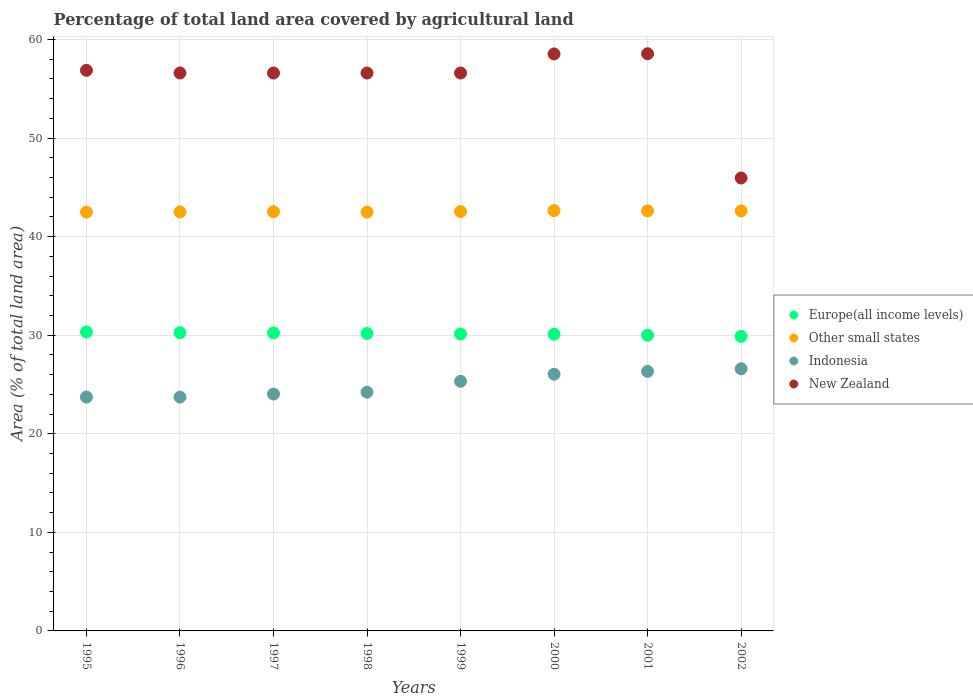What is the percentage of agricultural land in New Zealand in 1996?
Ensure brevity in your answer.  56.6. Across all years, what is the maximum percentage of agricultural land in Indonesia?
Give a very brief answer. 26.6. Across all years, what is the minimum percentage of agricultural land in New Zealand?
Your answer should be very brief. 45.95. In which year was the percentage of agricultural land in Other small states maximum?
Ensure brevity in your answer.  2000. What is the total percentage of agricultural land in Other small states in the graph?
Your answer should be compact. 340.41. What is the difference between the percentage of agricultural land in New Zealand in 1995 and that in 2000?
Offer a very short reply. -1.66. What is the difference between the percentage of agricultural land in New Zealand in 1998 and the percentage of agricultural land in Indonesia in 1997?
Your response must be concise. 32.57. What is the average percentage of agricultural land in Other small states per year?
Offer a terse response. 42.55. In the year 1999, what is the difference between the percentage of agricultural land in New Zealand and percentage of agricultural land in Europe(all income levels)?
Give a very brief answer. 26.47. What is the ratio of the percentage of agricultural land in Europe(all income levels) in 1997 to that in 2000?
Give a very brief answer. 1. Is the percentage of agricultural land in Indonesia in 1998 less than that in 2000?
Keep it short and to the point. Yes. Is the difference between the percentage of agricultural land in New Zealand in 1995 and 1999 greater than the difference between the percentage of agricultural land in Europe(all income levels) in 1995 and 1999?
Ensure brevity in your answer.  Yes. What is the difference between the highest and the second highest percentage of agricultural land in Indonesia?
Offer a very short reply. 0.27. What is the difference between the highest and the lowest percentage of agricultural land in Europe(all income levels)?
Provide a succinct answer. 0.45. Is the sum of the percentage of agricultural land in Europe(all income levels) in 2000 and 2001 greater than the maximum percentage of agricultural land in Indonesia across all years?
Keep it short and to the point. Yes. Is it the case that in every year, the sum of the percentage of agricultural land in Indonesia and percentage of agricultural land in New Zealand  is greater than the percentage of agricultural land in Other small states?
Offer a very short reply. Yes. Is the percentage of agricultural land in Other small states strictly greater than the percentage of agricultural land in Indonesia over the years?
Your answer should be very brief. Yes. Is the percentage of agricultural land in Europe(all income levels) strictly less than the percentage of agricultural land in Other small states over the years?
Provide a succinct answer. Yes. How many dotlines are there?
Your answer should be compact. 4. How many years are there in the graph?
Give a very brief answer. 8. What is the difference between two consecutive major ticks on the Y-axis?
Ensure brevity in your answer.  10. Does the graph contain any zero values?
Ensure brevity in your answer.  No. Where does the legend appear in the graph?
Your answer should be compact. Center right. What is the title of the graph?
Your answer should be very brief. Percentage of total land area covered by agricultural land. What is the label or title of the X-axis?
Provide a short and direct response. Years. What is the label or title of the Y-axis?
Give a very brief answer. Area (% of total land area). What is the Area (% of total land area) of Europe(all income levels) in 1995?
Ensure brevity in your answer.  30.33. What is the Area (% of total land area) of Other small states in 1995?
Offer a terse response. 42.49. What is the Area (% of total land area) in Indonesia in 1995?
Your response must be concise. 23.72. What is the Area (% of total land area) of New Zealand in 1995?
Ensure brevity in your answer.  56.87. What is the Area (% of total land area) of Europe(all income levels) in 1996?
Ensure brevity in your answer.  30.25. What is the Area (% of total land area) of Other small states in 1996?
Ensure brevity in your answer.  42.51. What is the Area (% of total land area) in Indonesia in 1996?
Your answer should be very brief. 23.72. What is the Area (% of total land area) of New Zealand in 1996?
Ensure brevity in your answer.  56.6. What is the Area (% of total land area) in Europe(all income levels) in 1997?
Your answer should be compact. 30.23. What is the Area (% of total land area) of Other small states in 1997?
Provide a short and direct response. 42.53. What is the Area (% of total land area) in Indonesia in 1997?
Your answer should be compact. 24.03. What is the Area (% of total land area) of New Zealand in 1997?
Keep it short and to the point. 56.6. What is the Area (% of total land area) of Europe(all income levels) in 1998?
Provide a succinct answer. 30.18. What is the Area (% of total land area) of Other small states in 1998?
Keep it short and to the point. 42.49. What is the Area (% of total land area) of Indonesia in 1998?
Offer a very short reply. 24.22. What is the Area (% of total land area) in New Zealand in 1998?
Provide a short and direct response. 56.6. What is the Area (% of total land area) in Europe(all income levels) in 1999?
Provide a short and direct response. 30.12. What is the Area (% of total land area) in Other small states in 1999?
Your answer should be very brief. 42.55. What is the Area (% of total land area) of Indonesia in 1999?
Make the answer very short. 25.32. What is the Area (% of total land area) in New Zealand in 1999?
Your response must be concise. 56.6. What is the Area (% of total land area) in Europe(all income levels) in 2000?
Your answer should be very brief. 30.1. What is the Area (% of total land area) in Other small states in 2000?
Give a very brief answer. 42.64. What is the Area (% of total land area) in Indonesia in 2000?
Make the answer very short. 26.04. What is the Area (% of total land area) in New Zealand in 2000?
Offer a very short reply. 58.54. What is the Area (% of total land area) in Europe(all income levels) in 2001?
Give a very brief answer. 30. What is the Area (% of total land area) of Other small states in 2001?
Provide a succinct answer. 42.61. What is the Area (% of total land area) in Indonesia in 2001?
Make the answer very short. 26.33. What is the Area (% of total land area) of New Zealand in 2001?
Ensure brevity in your answer.  58.55. What is the Area (% of total land area) in Europe(all income levels) in 2002?
Make the answer very short. 29.88. What is the Area (% of total land area) in Other small states in 2002?
Give a very brief answer. 42.61. What is the Area (% of total land area) of Indonesia in 2002?
Your answer should be very brief. 26.6. What is the Area (% of total land area) of New Zealand in 2002?
Keep it short and to the point. 45.95. Across all years, what is the maximum Area (% of total land area) of Europe(all income levels)?
Your answer should be compact. 30.33. Across all years, what is the maximum Area (% of total land area) of Other small states?
Your answer should be very brief. 42.64. Across all years, what is the maximum Area (% of total land area) of Indonesia?
Give a very brief answer. 26.6. Across all years, what is the maximum Area (% of total land area) in New Zealand?
Your answer should be compact. 58.55. Across all years, what is the minimum Area (% of total land area) in Europe(all income levels)?
Offer a very short reply. 29.88. Across all years, what is the minimum Area (% of total land area) of Other small states?
Provide a succinct answer. 42.49. Across all years, what is the minimum Area (% of total land area) in Indonesia?
Make the answer very short. 23.72. Across all years, what is the minimum Area (% of total land area) in New Zealand?
Make the answer very short. 45.95. What is the total Area (% of total land area) of Europe(all income levels) in the graph?
Give a very brief answer. 241.1. What is the total Area (% of total land area) of Other small states in the graph?
Your answer should be compact. 340.41. What is the total Area (% of total land area) of Indonesia in the graph?
Offer a very short reply. 199.98. What is the total Area (% of total land area) in New Zealand in the graph?
Your answer should be very brief. 446.31. What is the difference between the Area (% of total land area) in Europe(all income levels) in 1995 and that in 1996?
Offer a very short reply. 0.08. What is the difference between the Area (% of total land area) of Other small states in 1995 and that in 1996?
Make the answer very short. -0.02. What is the difference between the Area (% of total land area) of Indonesia in 1995 and that in 1996?
Provide a short and direct response. 0.01. What is the difference between the Area (% of total land area) of New Zealand in 1995 and that in 1996?
Offer a terse response. 0.27. What is the difference between the Area (% of total land area) in Europe(all income levels) in 1995 and that in 1997?
Your answer should be very brief. 0.1. What is the difference between the Area (% of total land area) of Other small states in 1995 and that in 1997?
Your response must be concise. -0.04. What is the difference between the Area (% of total land area) of Indonesia in 1995 and that in 1997?
Give a very brief answer. -0.3. What is the difference between the Area (% of total land area) of New Zealand in 1995 and that in 1997?
Offer a very short reply. 0.27. What is the difference between the Area (% of total land area) of Europe(all income levels) in 1995 and that in 1998?
Provide a succinct answer. 0.16. What is the difference between the Area (% of total land area) in Other small states in 1995 and that in 1998?
Offer a terse response. -0. What is the difference between the Area (% of total land area) in Indonesia in 1995 and that in 1998?
Offer a terse response. -0.5. What is the difference between the Area (% of total land area) in New Zealand in 1995 and that in 1998?
Your response must be concise. 0.27. What is the difference between the Area (% of total land area) in Europe(all income levels) in 1995 and that in 1999?
Offer a very short reply. 0.21. What is the difference between the Area (% of total land area) of Other small states in 1995 and that in 1999?
Ensure brevity in your answer.  -0.06. What is the difference between the Area (% of total land area) in Indonesia in 1995 and that in 1999?
Make the answer very short. -1.6. What is the difference between the Area (% of total land area) of New Zealand in 1995 and that in 1999?
Offer a terse response. 0.27. What is the difference between the Area (% of total land area) in Europe(all income levels) in 1995 and that in 2000?
Provide a short and direct response. 0.23. What is the difference between the Area (% of total land area) in Other small states in 1995 and that in 2000?
Provide a succinct answer. -0.15. What is the difference between the Area (% of total land area) in Indonesia in 1995 and that in 2000?
Give a very brief answer. -2.32. What is the difference between the Area (% of total land area) of New Zealand in 1995 and that in 2000?
Your answer should be compact. -1.66. What is the difference between the Area (% of total land area) of Europe(all income levels) in 1995 and that in 2001?
Offer a terse response. 0.34. What is the difference between the Area (% of total land area) of Other small states in 1995 and that in 2001?
Your answer should be very brief. -0.13. What is the difference between the Area (% of total land area) in Indonesia in 1995 and that in 2001?
Provide a short and direct response. -2.61. What is the difference between the Area (% of total land area) in New Zealand in 1995 and that in 2001?
Offer a terse response. -1.68. What is the difference between the Area (% of total land area) in Europe(all income levels) in 1995 and that in 2002?
Ensure brevity in your answer.  0.45. What is the difference between the Area (% of total land area) in Other small states in 1995 and that in 2002?
Provide a succinct answer. -0.12. What is the difference between the Area (% of total land area) of Indonesia in 1995 and that in 2002?
Your answer should be very brief. -2.87. What is the difference between the Area (% of total land area) of New Zealand in 1995 and that in 2002?
Provide a succinct answer. 10.92. What is the difference between the Area (% of total land area) of Europe(all income levels) in 1996 and that in 1997?
Your response must be concise. 0.02. What is the difference between the Area (% of total land area) of Other small states in 1996 and that in 1997?
Your answer should be compact. -0.02. What is the difference between the Area (% of total land area) of Indonesia in 1996 and that in 1997?
Keep it short and to the point. -0.31. What is the difference between the Area (% of total land area) in New Zealand in 1996 and that in 1997?
Ensure brevity in your answer.  0. What is the difference between the Area (% of total land area) of Europe(all income levels) in 1996 and that in 1998?
Provide a short and direct response. 0.08. What is the difference between the Area (% of total land area) in Other small states in 1996 and that in 1998?
Give a very brief answer. 0.02. What is the difference between the Area (% of total land area) of Indonesia in 1996 and that in 1998?
Offer a very short reply. -0.5. What is the difference between the Area (% of total land area) of New Zealand in 1996 and that in 1998?
Make the answer very short. 0. What is the difference between the Area (% of total land area) of Europe(all income levels) in 1996 and that in 1999?
Make the answer very short. 0.13. What is the difference between the Area (% of total land area) of Other small states in 1996 and that in 1999?
Your answer should be compact. -0.04. What is the difference between the Area (% of total land area) of Indonesia in 1996 and that in 1999?
Provide a succinct answer. -1.61. What is the difference between the Area (% of total land area) of New Zealand in 1996 and that in 1999?
Ensure brevity in your answer.  0. What is the difference between the Area (% of total land area) in Europe(all income levels) in 1996 and that in 2000?
Your answer should be very brief. 0.15. What is the difference between the Area (% of total land area) in Other small states in 1996 and that in 2000?
Give a very brief answer. -0.13. What is the difference between the Area (% of total land area) in Indonesia in 1996 and that in 2000?
Your answer should be very brief. -2.32. What is the difference between the Area (% of total land area) of New Zealand in 1996 and that in 2000?
Offer a very short reply. -1.93. What is the difference between the Area (% of total land area) in Europe(all income levels) in 1996 and that in 2001?
Make the answer very short. 0.26. What is the difference between the Area (% of total land area) in Other small states in 1996 and that in 2001?
Your answer should be compact. -0.1. What is the difference between the Area (% of total land area) in Indonesia in 1996 and that in 2001?
Ensure brevity in your answer.  -2.61. What is the difference between the Area (% of total land area) in New Zealand in 1996 and that in 2001?
Your answer should be very brief. -1.95. What is the difference between the Area (% of total land area) in Europe(all income levels) in 1996 and that in 2002?
Offer a very short reply. 0.37. What is the difference between the Area (% of total land area) in Other small states in 1996 and that in 2002?
Provide a succinct answer. -0.09. What is the difference between the Area (% of total land area) of Indonesia in 1996 and that in 2002?
Offer a terse response. -2.88. What is the difference between the Area (% of total land area) of New Zealand in 1996 and that in 2002?
Offer a terse response. 10.65. What is the difference between the Area (% of total land area) in Europe(all income levels) in 1997 and that in 1998?
Provide a succinct answer. 0.05. What is the difference between the Area (% of total land area) in Other small states in 1997 and that in 1998?
Offer a terse response. 0.04. What is the difference between the Area (% of total land area) in Indonesia in 1997 and that in 1998?
Make the answer very short. -0.19. What is the difference between the Area (% of total land area) of Europe(all income levels) in 1997 and that in 1999?
Your answer should be very brief. 0.11. What is the difference between the Area (% of total land area) in Other small states in 1997 and that in 1999?
Offer a terse response. -0.02. What is the difference between the Area (% of total land area) of Indonesia in 1997 and that in 1999?
Your answer should be very brief. -1.3. What is the difference between the Area (% of total land area) of New Zealand in 1997 and that in 1999?
Your response must be concise. 0. What is the difference between the Area (% of total land area) of Europe(all income levels) in 1997 and that in 2000?
Offer a terse response. 0.13. What is the difference between the Area (% of total land area) of Other small states in 1997 and that in 2000?
Your answer should be compact. -0.11. What is the difference between the Area (% of total land area) in Indonesia in 1997 and that in 2000?
Provide a short and direct response. -2.01. What is the difference between the Area (% of total land area) in New Zealand in 1997 and that in 2000?
Offer a terse response. -1.94. What is the difference between the Area (% of total land area) in Europe(all income levels) in 1997 and that in 2001?
Provide a succinct answer. 0.23. What is the difference between the Area (% of total land area) of Other small states in 1997 and that in 2001?
Your answer should be compact. -0.09. What is the difference between the Area (% of total land area) in Indonesia in 1997 and that in 2001?
Your answer should be very brief. -2.3. What is the difference between the Area (% of total land area) in New Zealand in 1997 and that in 2001?
Keep it short and to the point. -1.96. What is the difference between the Area (% of total land area) of Europe(all income levels) in 1997 and that in 2002?
Your response must be concise. 0.35. What is the difference between the Area (% of total land area) of Other small states in 1997 and that in 2002?
Offer a very short reply. -0.08. What is the difference between the Area (% of total land area) of Indonesia in 1997 and that in 2002?
Keep it short and to the point. -2.57. What is the difference between the Area (% of total land area) in New Zealand in 1997 and that in 2002?
Your answer should be compact. 10.65. What is the difference between the Area (% of total land area) of Europe(all income levels) in 1998 and that in 1999?
Your answer should be very brief. 0.05. What is the difference between the Area (% of total land area) in Other small states in 1998 and that in 1999?
Keep it short and to the point. -0.06. What is the difference between the Area (% of total land area) of Indonesia in 1998 and that in 1999?
Your answer should be compact. -1.1. What is the difference between the Area (% of total land area) of Europe(all income levels) in 1998 and that in 2000?
Your response must be concise. 0.07. What is the difference between the Area (% of total land area) in Other small states in 1998 and that in 2000?
Offer a terse response. -0.15. What is the difference between the Area (% of total land area) in Indonesia in 1998 and that in 2000?
Offer a terse response. -1.82. What is the difference between the Area (% of total land area) in New Zealand in 1998 and that in 2000?
Provide a short and direct response. -1.94. What is the difference between the Area (% of total land area) of Europe(all income levels) in 1998 and that in 2001?
Keep it short and to the point. 0.18. What is the difference between the Area (% of total land area) of Other small states in 1998 and that in 2001?
Offer a very short reply. -0.13. What is the difference between the Area (% of total land area) of Indonesia in 1998 and that in 2001?
Give a very brief answer. -2.11. What is the difference between the Area (% of total land area) of New Zealand in 1998 and that in 2001?
Keep it short and to the point. -1.96. What is the difference between the Area (% of total land area) of Europe(all income levels) in 1998 and that in 2002?
Provide a succinct answer. 0.29. What is the difference between the Area (% of total land area) in Other small states in 1998 and that in 2002?
Give a very brief answer. -0.12. What is the difference between the Area (% of total land area) of Indonesia in 1998 and that in 2002?
Make the answer very short. -2.38. What is the difference between the Area (% of total land area) in New Zealand in 1998 and that in 2002?
Keep it short and to the point. 10.65. What is the difference between the Area (% of total land area) in Europe(all income levels) in 1999 and that in 2000?
Ensure brevity in your answer.  0.02. What is the difference between the Area (% of total land area) in Other small states in 1999 and that in 2000?
Ensure brevity in your answer.  -0.09. What is the difference between the Area (% of total land area) in Indonesia in 1999 and that in 2000?
Ensure brevity in your answer.  -0.72. What is the difference between the Area (% of total land area) of New Zealand in 1999 and that in 2000?
Make the answer very short. -1.94. What is the difference between the Area (% of total land area) in Europe(all income levels) in 1999 and that in 2001?
Your answer should be very brief. 0.13. What is the difference between the Area (% of total land area) of Other small states in 1999 and that in 2001?
Give a very brief answer. -0.07. What is the difference between the Area (% of total land area) in Indonesia in 1999 and that in 2001?
Provide a succinct answer. -1.01. What is the difference between the Area (% of total land area) of New Zealand in 1999 and that in 2001?
Make the answer very short. -1.96. What is the difference between the Area (% of total land area) in Europe(all income levels) in 1999 and that in 2002?
Make the answer very short. 0.24. What is the difference between the Area (% of total land area) in Other small states in 1999 and that in 2002?
Offer a terse response. -0.06. What is the difference between the Area (% of total land area) of Indonesia in 1999 and that in 2002?
Provide a succinct answer. -1.27. What is the difference between the Area (% of total land area) in New Zealand in 1999 and that in 2002?
Provide a short and direct response. 10.65. What is the difference between the Area (% of total land area) in Europe(all income levels) in 2000 and that in 2001?
Make the answer very short. 0.11. What is the difference between the Area (% of total land area) of Other small states in 2000 and that in 2001?
Keep it short and to the point. 0.02. What is the difference between the Area (% of total land area) of Indonesia in 2000 and that in 2001?
Your answer should be very brief. -0.29. What is the difference between the Area (% of total land area) of New Zealand in 2000 and that in 2001?
Your answer should be very brief. -0.02. What is the difference between the Area (% of total land area) of Europe(all income levels) in 2000 and that in 2002?
Your answer should be very brief. 0.22. What is the difference between the Area (% of total land area) in Other small states in 2000 and that in 2002?
Offer a terse response. 0.03. What is the difference between the Area (% of total land area) in Indonesia in 2000 and that in 2002?
Make the answer very short. -0.55. What is the difference between the Area (% of total land area) in New Zealand in 2000 and that in 2002?
Provide a short and direct response. 12.59. What is the difference between the Area (% of total land area) of Europe(all income levels) in 2001 and that in 2002?
Offer a very short reply. 0.11. What is the difference between the Area (% of total land area) of Other small states in 2001 and that in 2002?
Provide a succinct answer. 0.01. What is the difference between the Area (% of total land area) of Indonesia in 2001 and that in 2002?
Give a very brief answer. -0.27. What is the difference between the Area (% of total land area) of New Zealand in 2001 and that in 2002?
Your answer should be compact. 12.6. What is the difference between the Area (% of total land area) of Europe(all income levels) in 1995 and the Area (% of total land area) of Other small states in 1996?
Keep it short and to the point. -12.18. What is the difference between the Area (% of total land area) in Europe(all income levels) in 1995 and the Area (% of total land area) in Indonesia in 1996?
Keep it short and to the point. 6.61. What is the difference between the Area (% of total land area) in Europe(all income levels) in 1995 and the Area (% of total land area) in New Zealand in 1996?
Make the answer very short. -26.27. What is the difference between the Area (% of total land area) of Other small states in 1995 and the Area (% of total land area) of Indonesia in 1996?
Provide a succinct answer. 18.77. What is the difference between the Area (% of total land area) of Other small states in 1995 and the Area (% of total land area) of New Zealand in 1996?
Keep it short and to the point. -14.12. What is the difference between the Area (% of total land area) of Indonesia in 1995 and the Area (% of total land area) of New Zealand in 1996?
Offer a terse response. -32.88. What is the difference between the Area (% of total land area) in Europe(all income levels) in 1995 and the Area (% of total land area) in Other small states in 1997?
Provide a succinct answer. -12.2. What is the difference between the Area (% of total land area) in Europe(all income levels) in 1995 and the Area (% of total land area) in Indonesia in 1997?
Keep it short and to the point. 6.3. What is the difference between the Area (% of total land area) in Europe(all income levels) in 1995 and the Area (% of total land area) in New Zealand in 1997?
Provide a short and direct response. -26.27. What is the difference between the Area (% of total land area) in Other small states in 1995 and the Area (% of total land area) in Indonesia in 1997?
Keep it short and to the point. 18.46. What is the difference between the Area (% of total land area) of Other small states in 1995 and the Area (% of total land area) of New Zealand in 1997?
Keep it short and to the point. -14.11. What is the difference between the Area (% of total land area) of Indonesia in 1995 and the Area (% of total land area) of New Zealand in 1997?
Your answer should be compact. -32.87. What is the difference between the Area (% of total land area) of Europe(all income levels) in 1995 and the Area (% of total land area) of Other small states in 1998?
Give a very brief answer. -12.16. What is the difference between the Area (% of total land area) in Europe(all income levels) in 1995 and the Area (% of total land area) in Indonesia in 1998?
Make the answer very short. 6.11. What is the difference between the Area (% of total land area) of Europe(all income levels) in 1995 and the Area (% of total land area) of New Zealand in 1998?
Provide a short and direct response. -26.27. What is the difference between the Area (% of total land area) of Other small states in 1995 and the Area (% of total land area) of Indonesia in 1998?
Your answer should be very brief. 18.27. What is the difference between the Area (% of total land area) in Other small states in 1995 and the Area (% of total land area) in New Zealand in 1998?
Your response must be concise. -14.11. What is the difference between the Area (% of total land area) of Indonesia in 1995 and the Area (% of total land area) of New Zealand in 1998?
Ensure brevity in your answer.  -32.87. What is the difference between the Area (% of total land area) of Europe(all income levels) in 1995 and the Area (% of total land area) of Other small states in 1999?
Your response must be concise. -12.21. What is the difference between the Area (% of total land area) of Europe(all income levels) in 1995 and the Area (% of total land area) of Indonesia in 1999?
Offer a terse response. 5.01. What is the difference between the Area (% of total land area) of Europe(all income levels) in 1995 and the Area (% of total land area) of New Zealand in 1999?
Offer a very short reply. -26.27. What is the difference between the Area (% of total land area) in Other small states in 1995 and the Area (% of total land area) in Indonesia in 1999?
Provide a succinct answer. 17.16. What is the difference between the Area (% of total land area) in Other small states in 1995 and the Area (% of total land area) in New Zealand in 1999?
Offer a terse response. -14.11. What is the difference between the Area (% of total land area) of Indonesia in 1995 and the Area (% of total land area) of New Zealand in 1999?
Your response must be concise. -32.87. What is the difference between the Area (% of total land area) of Europe(all income levels) in 1995 and the Area (% of total land area) of Other small states in 2000?
Ensure brevity in your answer.  -12.31. What is the difference between the Area (% of total land area) in Europe(all income levels) in 1995 and the Area (% of total land area) in Indonesia in 2000?
Make the answer very short. 4.29. What is the difference between the Area (% of total land area) of Europe(all income levels) in 1995 and the Area (% of total land area) of New Zealand in 2000?
Keep it short and to the point. -28.2. What is the difference between the Area (% of total land area) in Other small states in 1995 and the Area (% of total land area) in Indonesia in 2000?
Provide a succinct answer. 16.44. What is the difference between the Area (% of total land area) of Other small states in 1995 and the Area (% of total land area) of New Zealand in 2000?
Provide a succinct answer. -16.05. What is the difference between the Area (% of total land area) of Indonesia in 1995 and the Area (% of total land area) of New Zealand in 2000?
Make the answer very short. -34.81. What is the difference between the Area (% of total land area) of Europe(all income levels) in 1995 and the Area (% of total land area) of Other small states in 2001?
Offer a very short reply. -12.28. What is the difference between the Area (% of total land area) of Europe(all income levels) in 1995 and the Area (% of total land area) of Indonesia in 2001?
Offer a very short reply. 4. What is the difference between the Area (% of total land area) of Europe(all income levels) in 1995 and the Area (% of total land area) of New Zealand in 2001?
Offer a very short reply. -28.22. What is the difference between the Area (% of total land area) in Other small states in 1995 and the Area (% of total land area) in Indonesia in 2001?
Provide a short and direct response. 16.16. What is the difference between the Area (% of total land area) of Other small states in 1995 and the Area (% of total land area) of New Zealand in 2001?
Give a very brief answer. -16.07. What is the difference between the Area (% of total land area) in Indonesia in 1995 and the Area (% of total land area) in New Zealand in 2001?
Your answer should be very brief. -34.83. What is the difference between the Area (% of total land area) of Europe(all income levels) in 1995 and the Area (% of total land area) of Other small states in 2002?
Your answer should be very brief. -12.27. What is the difference between the Area (% of total land area) in Europe(all income levels) in 1995 and the Area (% of total land area) in Indonesia in 2002?
Keep it short and to the point. 3.74. What is the difference between the Area (% of total land area) in Europe(all income levels) in 1995 and the Area (% of total land area) in New Zealand in 2002?
Provide a succinct answer. -15.62. What is the difference between the Area (% of total land area) of Other small states in 1995 and the Area (% of total land area) of Indonesia in 2002?
Provide a succinct answer. 15.89. What is the difference between the Area (% of total land area) of Other small states in 1995 and the Area (% of total land area) of New Zealand in 2002?
Offer a very short reply. -3.46. What is the difference between the Area (% of total land area) of Indonesia in 1995 and the Area (% of total land area) of New Zealand in 2002?
Give a very brief answer. -22.23. What is the difference between the Area (% of total land area) of Europe(all income levels) in 1996 and the Area (% of total land area) of Other small states in 1997?
Give a very brief answer. -12.27. What is the difference between the Area (% of total land area) of Europe(all income levels) in 1996 and the Area (% of total land area) of Indonesia in 1997?
Your response must be concise. 6.23. What is the difference between the Area (% of total land area) of Europe(all income levels) in 1996 and the Area (% of total land area) of New Zealand in 1997?
Your response must be concise. -26.34. What is the difference between the Area (% of total land area) of Other small states in 1996 and the Area (% of total land area) of Indonesia in 1997?
Give a very brief answer. 18.48. What is the difference between the Area (% of total land area) in Other small states in 1996 and the Area (% of total land area) in New Zealand in 1997?
Your answer should be very brief. -14.09. What is the difference between the Area (% of total land area) of Indonesia in 1996 and the Area (% of total land area) of New Zealand in 1997?
Your answer should be very brief. -32.88. What is the difference between the Area (% of total land area) of Europe(all income levels) in 1996 and the Area (% of total land area) of Other small states in 1998?
Your answer should be very brief. -12.23. What is the difference between the Area (% of total land area) of Europe(all income levels) in 1996 and the Area (% of total land area) of Indonesia in 1998?
Provide a succinct answer. 6.03. What is the difference between the Area (% of total land area) in Europe(all income levels) in 1996 and the Area (% of total land area) in New Zealand in 1998?
Give a very brief answer. -26.34. What is the difference between the Area (% of total land area) of Other small states in 1996 and the Area (% of total land area) of Indonesia in 1998?
Your answer should be compact. 18.29. What is the difference between the Area (% of total land area) of Other small states in 1996 and the Area (% of total land area) of New Zealand in 1998?
Your answer should be compact. -14.09. What is the difference between the Area (% of total land area) in Indonesia in 1996 and the Area (% of total land area) in New Zealand in 1998?
Ensure brevity in your answer.  -32.88. What is the difference between the Area (% of total land area) in Europe(all income levels) in 1996 and the Area (% of total land area) in Other small states in 1999?
Your response must be concise. -12.29. What is the difference between the Area (% of total land area) of Europe(all income levels) in 1996 and the Area (% of total land area) of Indonesia in 1999?
Your response must be concise. 4.93. What is the difference between the Area (% of total land area) in Europe(all income levels) in 1996 and the Area (% of total land area) in New Zealand in 1999?
Your answer should be very brief. -26.34. What is the difference between the Area (% of total land area) of Other small states in 1996 and the Area (% of total land area) of Indonesia in 1999?
Offer a very short reply. 17.19. What is the difference between the Area (% of total land area) of Other small states in 1996 and the Area (% of total land area) of New Zealand in 1999?
Offer a terse response. -14.09. What is the difference between the Area (% of total land area) in Indonesia in 1996 and the Area (% of total land area) in New Zealand in 1999?
Keep it short and to the point. -32.88. What is the difference between the Area (% of total land area) of Europe(all income levels) in 1996 and the Area (% of total land area) of Other small states in 2000?
Offer a terse response. -12.38. What is the difference between the Area (% of total land area) of Europe(all income levels) in 1996 and the Area (% of total land area) of Indonesia in 2000?
Make the answer very short. 4.21. What is the difference between the Area (% of total land area) of Europe(all income levels) in 1996 and the Area (% of total land area) of New Zealand in 2000?
Provide a succinct answer. -28.28. What is the difference between the Area (% of total land area) of Other small states in 1996 and the Area (% of total land area) of Indonesia in 2000?
Offer a terse response. 16.47. What is the difference between the Area (% of total land area) in Other small states in 1996 and the Area (% of total land area) in New Zealand in 2000?
Provide a short and direct response. -16.02. What is the difference between the Area (% of total land area) of Indonesia in 1996 and the Area (% of total land area) of New Zealand in 2000?
Provide a short and direct response. -34.82. What is the difference between the Area (% of total land area) in Europe(all income levels) in 1996 and the Area (% of total land area) in Other small states in 2001?
Ensure brevity in your answer.  -12.36. What is the difference between the Area (% of total land area) in Europe(all income levels) in 1996 and the Area (% of total land area) in Indonesia in 2001?
Make the answer very short. 3.92. What is the difference between the Area (% of total land area) of Europe(all income levels) in 1996 and the Area (% of total land area) of New Zealand in 2001?
Your response must be concise. -28.3. What is the difference between the Area (% of total land area) of Other small states in 1996 and the Area (% of total land area) of Indonesia in 2001?
Offer a very short reply. 16.18. What is the difference between the Area (% of total land area) in Other small states in 1996 and the Area (% of total land area) in New Zealand in 2001?
Your answer should be compact. -16.04. What is the difference between the Area (% of total land area) in Indonesia in 1996 and the Area (% of total land area) in New Zealand in 2001?
Make the answer very short. -34.84. What is the difference between the Area (% of total land area) in Europe(all income levels) in 1996 and the Area (% of total land area) in Other small states in 2002?
Ensure brevity in your answer.  -12.35. What is the difference between the Area (% of total land area) of Europe(all income levels) in 1996 and the Area (% of total land area) of Indonesia in 2002?
Offer a very short reply. 3.66. What is the difference between the Area (% of total land area) in Europe(all income levels) in 1996 and the Area (% of total land area) in New Zealand in 2002?
Offer a terse response. -15.7. What is the difference between the Area (% of total land area) in Other small states in 1996 and the Area (% of total land area) in Indonesia in 2002?
Ensure brevity in your answer.  15.91. What is the difference between the Area (% of total land area) in Other small states in 1996 and the Area (% of total land area) in New Zealand in 2002?
Give a very brief answer. -3.44. What is the difference between the Area (% of total land area) in Indonesia in 1996 and the Area (% of total land area) in New Zealand in 2002?
Your answer should be very brief. -22.23. What is the difference between the Area (% of total land area) of Europe(all income levels) in 1997 and the Area (% of total land area) of Other small states in 1998?
Offer a very short reply. -12.26. What is the difference between the Area (% of total land area) of Europe(all income levels) in 1997 and the Area (% of total land area) of Indonesia in 1998?
Your answer should be very brief. 6.01. What is the difference between the Area (% of total land area) in Europe(all income levels) in 1997 and the Area (% of total land area) in New Zealand in 1998?
Make the answer very short. -26.37. What is the difference between the Area (% of total land area) in Other small states in 1997 and the Area (% of total land area) in Indonesia in 1998?
Your response must be concise. 18.31. What is the difference between the Area (% of total land area) in Other small states in 1997 and the Area (% of total land area) in New Zealand in 1998?
Give a very brief answer. -14.07. What is the difference between the Area (% of total land area) in Indonesia in 1997 and the Area (% of total land area) in New Zealand in 1998?
Make the answer very short. -32.57. What is the difference between the Area (% of total land area) in Europe(all income levels) in 1997 and the Area (% of total land area) in Other small states in 1999?
Offer a very short reply. -12.32. What is the difference between the Area (% of total land area) of Europe(all income levels) in 1997 and the Area (% of total land area) of Indonesia in 1999?
Ensure brevity in your answer.  4.91. What is the difference between the Area (% of total land area) in Europe(all income levels) in 1997 and the Area (% of total land area) in New Zealand in 1999?
Your answer should be very brief. -26.37. What is the difference between the Area (% of total land area) in Other small states in 1997 and the Area (% of total land area) in Indonesia in 1999?
Provide a succinct answer. 17.2. What is the difference between the Area (% of total land area) in Other small states in 1997 and the Area (% of total land area) in New Zealand in 1999?
Your answer should be compact. -14.07. What is the difference between the Area (% of total land area) in Indonesia in 1997 and the Area (% of total land area) in New Zealand in 1999?
Provide a short and direct response. -32.57. What is the difference between the Area (% of total land area) of Europe(all income levels) in 1997 and the Area (% of total land area) of Other small states in 2000?
Offer a very short reply. -12.41. What is the difference between the Area (% of total land area) in Europe(all income levels) in 1997 and the Area (% of total land area) in Indonesia in 2000?
Your response must be concise. 4.19. What is the difference between the Area (% of total land area) in Europe(all income levels) in 1997 and the Area (% of total land area) in New Zealand in 2000?
Your answer should be compact. -28.31. What is the difference between the Area (% of total land area) in Other small states in 1997 and the Area (% of total land area) in Indonesia in 2000?
Make the answer very short. 16.49. What is the difference between the Area (% of total land area) of Other small states in 1997 and the Area (% of total land area) of New Zealand in 2000?
Your answer should be compact. -16.01. What is the difference between the Area (% of total land area) in Indonesia in 1997 and the Area (% of total land area) in New Zealand in 2000?
Ensure brevity in your answer.  -34.51. What is the difference between the Area (% of total land area) of Europe(all income levels) in 1997 and the Area (% of total land area) of Other small states in 2001?
Offer a very short reply. -12.38. What is the difference between the Area (% of total land area) of Europe(all income levels) in 1997 and the Area (% of total land area) of Indonesia in 2001?
Offer a very short reply. 3.9. What is the difference between the Area (% of total land area) of Europe(all income levels) in 1997 and the Area (% of total land area) of New Zealand in 2001?
Your answer should be very brief. -28.32. What is the difference between the Area (% of total land area) of Other small states in 1997 and the Area (% of total land area) of Indonesia in 2001?
Keep it short and to the point. 16.2. What is the difference between the Area (% of total land area) in Other small states in 1997 and the Area (% of total land area) in New Zealand in 2001?
Keep it short and to the point. -16.03. What is the difference between the Area (% of total land area) in Indonesia in 1997 and the Area (% of total land area) in New Zealand in 2001?
Ensure brevity in your answer.  -34.53. What is the difference between the Area (% of total land area) in Europe(all income levels) in 1997 and the Area (% of total land area) in Other small states in 2002?
Provide a short and direct response. -12.38. What is the difference between the Area (% of total land area) in Europe(all income levels) in 1997 and the Area (% of total land area) in Indonesia in 2002?
Make the answer very short. 3.63. What is the difference between the Area (% of total land area) in Europe(all income levels) in 1997 and the Area (% of total land area) in New Zealand in 2002?
Make the answer very short. -15.72. What is the difference between the Area (% of total land area) in Other small states in 1997 and the Area (% of total land area) in Indonesia in 2002?
Make the answer very short. 15.93. What is the difference between the Area (% of total land area) of Other small states in 1997 and the Area (% of total land area) of New Zealand in 2002?
Provide a short and direct response. -3.42. What is the difference between the Area (% of total land area) of Indonesia in 1997 and the Area (% of total land area) of New Zealand in 2002?
Give a very brief answer. -21.92. What is the difference between the Area (% of total land area) in Europe(all income levels) in 1998 and the Area (% of total land area) in Other small states in 1999?
Give a very brief answer. -12.37. What is the difference between the Area (% of total land area) in Europe(all income levels) in 1998 and the Area (% of total land area) in Indonesia in 1999?
Provide a short and direct response. 4.85. What is the difference between the Area (% of total land area) of Europe(all income levels) in 1998 and the Area (% of total land area) of New Zealand in 1999?
Make the answer very short. -26.42. What is the difference between the Area (% of total land area) of Other small states in 1998 and the Area (% of total land area) of Indonesia in 1999?
Your response must be concise. 17.16. What is the difference between the Area (% of total land area) of Other small states in 1998 and the Area (% of total land area) of New Zealand in 1999?
Keep it short and to the point. -14.11. What is the difference between the Area (% of total land area) in Indonesia in 1998 and the Area (% of total land area) in New Zealand in 1999?
Your response must be concise. -32.38. What is the difference between the Area (% of total land area) of Europe(all income levels) in 1998 and the Area (% of total land area) of Other small states in 2000?
Ensure brevity in your answer.  -12.46. What is the difference between the Area (% of total land area) in Europe(all income levels) in 1998 and the Area (% of total land area) in Indonesia in 2000?
Offer a terse response. 4.13. What is the difference between the Area (% of total land area) in Europe(all income levels) in 1998 and the Area (% of total land area) in New Zealand in 2000?
Your answer should be very brief. -28.36. What is the difference between the Area (% of total land area) of Other small states in 1998 and the Area (% of total land area) of Indonesia in 2000?
Your answer should be very brief. 16.45. What is the difference between the Area (% of total land area) in Other small states in 1998 and the Area (% of total land area) in New Zealand in 2000?
Provide a succinct answer. -16.05. What is the difference between the Area (% of total land area) of Indonesia in 1998 and the Area (% of total land area) of New Zealand in 2000?
Your answer should be compact. -34.32. What is the difference between the Area (% of total land area) in Europe(all income levels) in 1998 and the Area (% of total land area) in Other small states in 2001?
Give a very brief answer. -12.44. What is the difference between the Area (% of total land area) in Europe(all income levels) in 1998 and the Area (% of total land area) in Indonesia in 2001?
Keep it short and to the point. 3.85. What is the difference between the Area (% of total land area) in Europe(all income levels) in 1998 and the Area (% of total land area) in New Zealand in 2001?
Offer a terse response. -28.38. What is the difference between the Area (% of total land area) in Other small states in 1998 and the Area (% of total land area) in Indonesia in 2001?
Your answer should be very brief. 16.16. What is the difference between the Area (% of total land area) in Other small states in 1998 and the Area (% of total land area) in New Zealand in 2001?
Provide a short and direct response. -16.07. What is the difference between the Area (% of total land area) in Indonesia in 1998 and the Area (% of total land area) in New Zealand in 2001?
Provide a succinct answer. -34.33. What is the difference between the Area (% of total land area) in Europe(all income levels) in 1998 and the Area (% of total land area) in Other small states in 2002?
Your answer should be compact. -12.43. What is the difference between the Area (% of total land area) in Europe(all income levels) in 1998 and the Area (% of total land area) in Indonesia in 2002?
Your response must be concise. 3.58. What is the difference between the Area (% of total land area) of Europe(all income levels) in 1998 and the Area (% of total land area) of New Zealand in 2002?
Ensure brevity in your answer.  -15.77. What is the difference between the Area (% of total land area) in Other small states in 1998 and the Area (% of total land area) in Indonesia in 2002?
Your response must be concise. 15.89. What is the difference between the Area (% of total land area) of Other small states in 1998 and the Area (% of total land area) of New Zealand in 2002?
Your answer should be very brief. -3.46. What is the difference between the Area (% of total land area) of Indonesia in 1998 and the Area (% of total land area) of New Zealand in 2002?
Your answer should be very brief. -21.73. What is the difference between the Area (% of total land area) of Europe(all income levels) in 1999 and the Area (% of total land area) of Other small states in 2000?
Your answer should be compact. -12.51. What is the difference between the Area (% of total land area) in Europe(all income levels) in 1999 and the Area (% of total land area) in Indonesia in 2000?
Offer a terse response. 4.08. What is the difference between the Area (% of total land area) in Europe(all income levels) in 1999 and the Area (% of total land area) in New Zealand in 2000?
Offer a very short reply. -28.41. What is the difference between the Area (% of total land area) of Other small states in 1999 and the Area (% of total land area) of Indonesia in 2000?
Ensure brevity in your answer.  16.5. What is the difference between the Area (% of total land area) in Other small states in 1999 and the Area (% of total land area) in New Zealand in 2000?
Your answer should be compact. -15.99. What is the difference between the Area (% of total land area) of Indonesia in 1999 and the Area (% of total land area) of New Zealand in 2000?
Give a very brief answer. -33.21. What is the difference between the Area (% of total land area) in Europe(all income levels) in 1999 and the Area (% of total land area) in Other small states in 2001?
Your answer should be compact. -12.49. What is the difference between the Area (% of total land area) of Europe(all income levels) in 1999 and the Area (% of total land area) of Indonesia in 2001?
Your response must be concise. 3.79. What is the difference between the Area (% of total land area) in Europe(all income levels) in 1999 and the Area (% of total land area) in New Zealand in 2001?
Your answer should be compact. -28.43. What is the difference between the Area (% of total land area) of Other small states in 1999 and the Area (% of total land area) of Indonesia in 2001?
Make the answer very short. 16.22. What is the difference between the Area (% of total land area) in Other small states in 1999 and the Area (% of total land area) in New Zealand in 2001?
Your answer should be compact. -16.01. What is the difference between the Area (% of total land area) in Indonesia in 1999 and the Area (% of total land area) in New Zealand in 2001?
Keep it short and to the point. -33.23. What is the difference between the Area (% of total land area) in Europe(all income levels) in 1999 and the Area (% of total land area) in Other small states in 2002?
Provide a short and direct response. -12.48. What is the difference between the Area (% of total land area) of Europe(all income levels) in 1999 and the Area (% of total land area) of Indonesia in 2002?
Keep it short and to the point. 3.53. What is the difference between the Area (% of total land area) in Europe(all income levels) in 1999 and the Area (% of total land area) in New Zealand in 2002?
Your answer should be very brief. -15.83. What is the difference between the Area (% of total land area) in Other small states in 1999 and the Area (% of total land area) in Indonesia in 2002?
Your answer should be compact. 15.95. What is the difference between the Area (% of total land area) of Other small states in 1999 and the Area (% of total land area) of New Zealand in 2002?
Offer a terse response. -3.4. What is the difference between the Area (% of total land area) of Indonesia in 1999 and the Area (% of total land area) of New Zealand in 2002?
Your answer should be compact. -20.63. What is the difference between the Area (% of total land area) of Europe(all income levels) in 2000 and the Area (% of total land area) of Other small states in 2001?
Your response must be concise. -12.51. What is the difference between the Area (% of total land area) in Europe(all income levels) in 2000 and the Area (% of total land area) in Indonesia in 2001?
Ensure brevity in your answer.  3.77. What is the difference between the Area (% of total land area) in Europe(all income levels) in 2000 and the Area (% of total land area) in New Zealand in 2001?
Offer a very short reply. -28.45. What is the difference between the Area (% of total land area) in Other small states in 2000 and the Area (% of total land area) in Indonesia in 2001?
Make the answer very short. 16.31. What is the difference between the Area (% of total land area) in Other small states in 2000 and the Area (% of total land area) in New Zealand in 2001?
Your answer should be compact. -15.92. What is the difference between the Area (% of total land area) of Indonesia in 2000 and the Area (% of total land area) of New Zealand in 2001?
Offer a very short reply. -32.51. What is the difference between the Area (% of total land area) of Europe(all income levels) in 2000 and the Area (% of total land area) of Other small states in 2002?
Give a very brief answer. -12.5. What is the difference between the Area (% of total land area) of Europe(all income levels) in 2000 and the Area (% of total land area) of Indonesia in 2002?
Make the answer very short. 3.51. What is the difference between the Area (% of total land area) of Europe(all income levels) in 2000 and the Area (% of total land area) of New Zealand in 2002?
Make the answer very short. -15.85. What is the difference between the Area (% of total land area) of Other small states in 2000 and the Area (% of total land area) of Indonesia in 2002?
Make the answer very short. 16.04. What is the difference between the Area (% of total land area) of Other small states in 2000 and the Area (% of total land area) of New Zealand in 2002?
Offer a terse response. -3.31. What is the difference between the Area (% of total land area) in Indonesia in 2000 and the Area (% of total land area) in New Zealand in 2002?
Provide a short and direct response. -19.91. What is the difference between the Area (% of total land area) of Europe(all income levels) in 2001 and the Area (% of total land area) of Other small states in 2002?
Make the answer very short. -12.61. What is the difference between the Area (% of total land area) in Europe(all income levels) in 2001 and the Area (% of total land area) in Indonesia in 2002?
Provide a succinct answer. 3.4. What is the difference between the Area (% of total land area) in Europe(all income levels) in 2001 and the Area (% of total land area) in New Zealand in 2002?
Your answer should be compact. -15.95. What is the difference between the Area (% of total land area) in Other small states in 2001 and the Area (% of total land area) in Indonesia in 2002?
Make the answer very short. 16.02. What is the difference between the Area (% of total land area) in Other small states in 2001 and the Area (% of total land area) in New Zealand in 2002?
Make the answer very short. -3.34. What is the difference between the Area (% of total land area) of Indonesia in 2001 and the Area (% of total land area) of New Zealand in 2002?
Ensure brevity in your answer.  -19.62. What is the average Area (% of total land area) of Europe(all income levels) per year?
Your answer should be very brief. 30.14. What is the average Area (% of total land area) of Other small states per year?
Keep it short and to the point. 42.55. What is the average Area (% of total land area) of Indonesia per year?
Offer a very short reply. 25. What is the average Area (% of total land area) of New Zealand per year?
Offer a very short reply. 55.79. In the year 1995, what is the difference between the Area (% of total land area) of Europe(all income levels) and Area (% of total land area) of Other small states?
Offer a very short reply. -12.15. In the year 1995, what is the difference between the Area (% of total land area) in Europe(all income levels) and Area (% of total land area) in Indonesia?
Your answer should be very brief. 6.61. In the year 1995, what is the difference between the Area (% of total land area) of Europe(all income levels) and Area (% of total land area) of New Zealand?
Your answer should be compact. -26.54. In the year 1995, what is the difference between the Area (% of total land area) of Other small states and Area (% of total land area) of Indonesia?
Make the answer very short. 18.76. In the year 1995, what is the difference between the Area (% of total land area) of Other small states and Area (% of total land area) of New Zealand?
Offer a terse response. -14.39. In the year 1995, what is the difference between the Area (% of total land area) of Indonesia and Area (% of total land area) of New Zealand?
Provide a succinct answer. -33.15. In the year 1996, what is the difference between the Area (% of total land area) of Europe(all income levels) and Area (% of total land area) of Other small states?
Provide a succinct answer. -12.26. In the year 1996, what is the difference between the Area (% of total land area) in Europe(all income levels) and Area (% of total land area) in Indonesia?
Your answer should be very brief. 6.54. In the year 1996, what is the difference between the Area (% of total land area) of Europe(all income levels) and Area (% of total land area) of New Zealand?
Ensure brevity in your answer.  -26.35. In the year 1996, what is the difference between the Area (% of total land area) of Other small states and Area (% of total land area) of Indonesia?
Give a very brief answer. 18.79. In the year 1996, what is the difference between the Area (% of total land area) of Other small states and Area (% of total land area) of New Zealand?
Offer a terse response. -14.09. In the year 1996, what is the difference between the Area (% of total land area) of Indonesia and Area (% of total land area) of New Zealand?
Provide a succinct answer. -32.88. In the year 1997, what is the difference between the Area (% of total land area) of Europe(all income levels) and Area (% of total land area) of Other small states?
Your response must be concise. -12.3. In the year 1997, what is the difference between the Area (% of total land area) in Europe(all income levels) and Area (% of total land area) in Indonesia?
Offer a very short reply. 6.2. In the year 1997, what is the difference between the Area (% of total land area) in Europe(all income levels) and Area (% of total land area) in New Zealand?
Give a very brief answer. -26.37. In the year 1997, what is the difference between the Area (% of total land area) of Other small states and Area (% of total land area) of Indonesia?
Your answer should be compact. 18.5. In the year 1997, what is the difference between the Area (% of total land area) of Other small states and Area (% of total land area) of New Zealand?
Your answer should be compact. -14.07. In the year 1997, what is the difference between the Area (% of total land area) of Indonesia and Area (% of total land area) of New Zealand?
Keep it short and to the point. -32.57. In the year 1998, what is the difference between the Area (% of total land area) of Europe(all income levels) and Area (% of total land area) of Other small states?
Provide a short and direct response. -12.31. In the year 1998, what is the difference between the Area (% of total land area) in Europe(all income levels) and Area (% of total land area) in Indonesia?
Your response must be concise. 5.96. In the year 1998, what is the difference between the Area (% of total land area) of Europe(all income levels) and Area (% of total land area) of New Zealand?
Make the answer very short. -26.42. In the year 1998, what is the difference between the Area (% of total land area) in Other small states and Area (% of total land area) in Indonesia?
Keep it short and to the point. 18.27. In the year 1998, what is the difference between the Area (% of total land area) of Other small states and Area (% of total land area) of New Zealand?
Your answer should be compact. -14.11. In the year 1998, what is the difference between the Area (% of total land area) of Indonesia and Area (% of total land area) of New Zealand?
Your answer should be very brief. -32.38. In the year 1999, what is the difference between the Area (% of total land area) in Europe(all income levels) and Area (% of total land area) in Other small states?
Give a very brief answer. -12.42. In the year 1999, what is the difference between the Area (% of total land area) in Europe(all income levels) and Area (% of total land area) in Indonesia?
Your response must be concise. 4.8. In the year 1999, what is the difference between the Area (% of total land area) in Europe(all income levels) and Area (% of total land area) in New Zealand?
Offer a terse response. -26.47. In the year 1999, what is the difference between the Area (% of total land area) in Other small states and Area (% of total land area) in Indonesia?
Provide a short and direct response. 17.22. In the year 1999, what is the difference between the Area (% of total land area) in Other small states and Area (% of total land area) in New Zealand?
Offer a terse response. -14.05. In the year 1999, what is the difference between the Area (% of total land area) of Indonesia and Area (% of total land area) of New Zealand?
Make the answer very short. -31.27. In the year 2000, what is the difference between the Area (% of total land area) of Europe(all income levels) and Area (% of total land area) of Other small states?
Keep it short and to the point. -12.53. In the year 2000, what is the difference between the Area (% of total land area) in Europe(all income levels) and Area (% of total land area) in Indonesia?
Make the answer very short. 4.06. In the year 2000, what is the difference between the Area (% of total land area) in Europe(all income levels) and Area (% of total land area) in New Zealand?
Offer a very short reply. -28.43. In the year 2000, what is the difference between the Area (% of total land area) of Other small states and Area (% of total land area) of Indonesia?
Your answer should be compact. 16.59. In the year 2000, what is the difference between the Area (% of total land area) of Other small states and Area (% of total land area) of New Zealand?
Make the answer very short. -15.9. In the year 2000, what is the difference between the Area (% of total land area) of Indonesia and Area (% of total land area) of New Zealand?
Offer a terse response. -32.49. In the year 2001, what is the difference between the Area (% of total land area) of Europe(all income levels) and Area (% of total land area) of Other small states?
Ensure brevity in your answer.  -12.62. In the year 2001, what is the difference between the Area (% of total land area) of Europe(all income levels) and Area (% of total land area) of Indonesia?
Offer a terse response. 3.67. In the year 2001, what is the difference between the Area (% of total land area) in Europe(all income levels) and Area (% of total land area) in New Zealand?
Your answer should be very brief. -28.56. In the year 2001, what is the difference between the Area (% of total land area) in Other small states and Area (% of total land area) in Indonesia?
Make the answer very short. 16.28. In the year 2001, what is the difference between the Area (% of total land area) of Other small states and Area (% of total land area) of New Zealand?
Ensure brevity in your answer.  -15.94. In the year 2001, what is the difference between the Area (% of total land area) in Indonesia and Area (% of total land area) in New Zealand?
Your response must be concise. -32.22. In the year 2002, what is the difference between the Area (% of total land area) in Europe(all income levels) and Area (% of total land area) in Other small states?
Give a very brief answer. -12.72. In the year 2002, what is the difference between the Area (% of total land area) in Europe(all income levels) and Area (% of total land area) in Indonesia?
Your response must be concise. 3.29. In the year 2002, what is the difference between the Area (% of total land area) of Europe(all income levels) and Area (% of total land area) of New Zealand?
Offer a terse response. -16.07. In the year 2002, what is the difference between the Area (% of total land area) in Other small states and Area (% of total land area) in Indonesia?
Offer a terse response. 16.01. In the year 2002, what is the difference between the Area (% of total land area) of Other small states and Area (% of total land area) of New Zealand?
Make the answer very short. -3.34. In the year 2002, what is the difference between the Area (% of total land area) in Indonesia and Area (% of total land area) in New Zealand?
Give a very brief answer. -19.35. What is the ratio of the Area (% of total land area) of Europe(all income levels) in 1995 to that in 1996?
Keep it short and to the point. 1. What is the ratio of the Area (% of total land area) in New Zealand in 1995 to that in 1996?
Provide a short and direct response. 1. What is the ratio of the Area (% of total land area) of Other small states in 1995 to that in 1997?
Your answer should be very brief. 1. What is the ratio of the Area (% of total land area) of Indonesia in 1995 to that in 1997?
Provide a succinct answer. 0.99. What is the ratio of the Area (% of total land area) of New Zealand in 1995 to that in 1997?
Make the answer very short. 1. What is the ratio of the Area (% of total land area) of Europe(all income levels) in 1995 to that in 1998?
Provide a short and direct response. 1.01. What is the ratio of the Area (% of total land area) in Other small states in 1995 to that in 1998?
Provide a succinct answer. 1. What is the ratio of the Area (% of total land area) of Indonesia in 1995 to that in 1998?
Keep it short and to the point. 0.98. What is the ratio of the Area (% of total land area) in Europe(all income levels) in 1995 to that in 1999?
Your response must be concise. 1.01. What is the ratio of the Area (% of total land area) of Indonesia in 1995 to that in 1999?
Your response must be concise. 0.94. What is the ratio of the Area (% of total land area) of Europe(all income levels) in 1995 to that in 2000?
Provide a short and direct response. 1.01. What is the ratio of the Area (% of total land area) in Other small states in 1995 to that in 2000?
Your answer should be very brief. 1. What is the ratio of the Area (% of total land area) in Indonesia in 1995 to that in 2000?
Provide a succinct answer. 0.91. What is the ratio of the Area (% of total land area) of New Zealand in 1995 to that in 2000?
Make the answer very short. 0.97. What is the ratio of the Area (% of total land area) in Europe(all income levels) in 1995 to that in 2001?
Your answer should be very brief. 1.01. What is the ratio of the Area (% of total land area) in Indonesia in 1995 to that in 2001?
Provide a succinct answer. 0.9. What is the ratio of the Area (% of total land area) in New Zealand in 1995 to that in 2001?
Your response must be concise. 0.97. What is the ratio of the Area (% of total land area) of Other small states in 1995 to that in 2002?
Ensure brevity in your answer.  1. What is the ratio of the Area (% of total land area) of Indonesia in 1995 to that in 2002?
Offer a terse response. 0.89. What is the ratio of the Area (% of total land area) in New Zealand in 1995 to that in 2002?
Your response must be concise. 1.24. What is the ratio of the Area (% of total land area) of Other small states in 1996 to that in 1997?
Your answer should be very brief. 1. What is the ratio of the Area (% of total land area) of Indonesia in 1996 to that in 1997?
Offer a terse response. 0.99. What is the ratio of the Area (% of total land area) in New Zealand in 1996 to that in 1997?
Ensure brevity in your answer.  1. What is the ratio of the Area (% of total land area) of Other small states in 1996 to that in 1998?
Your answer should be very brief. 1. What is the ratio of the Area (% of total land area) in Indonesia in 1996 to that in 1998?
Your answer should be very brief. 0.98. What is the ratio of the Area (% of total land area) in Europe(all income levels) in 1996 to that in 1999?
Give a very brief answer. 1. What is the ratio of the Area (% of total land area) of Other small states in 1996 to that in 1999?
Your response must be concise. 1. What is the ratio of the Area (% of total land area) of Indonesia in 1996 to that in 1999?
Give a very brief answer. 0.94. What is the ratio of the Area (% of total land area) in New Zealand in 1996 to that in 1999?
Keep it short and to the point. 1. What is the ratio of the Area (% of total land area) in Europe(all income levels) in 1996 to that in 2000?
Make the answer very short. 1.01. What is the ratio of the Area (% of total land area) in Indonesia in 1996 to that in 2000?
Your response must be concise. 0.91. What is the ratio of the Area (% of total land area) in Europe(all income levels) in 1996 to that in 2001?
Give a very brief answer. 1.01. What is the ratio of the Area (% of total land area) in Indonesia in 1996 to that in 2001?
Make the answer very short. 0.9. What is the ratio of the Area (% of total land area) in New Zealand in 1996 to that in 2001?
Keep it short and to the point. 0.97. What is the ratio of the Area (% of total land area) of Europe(all income levels) in 1996 to that in 2002?
Your answer should be compact. 1.01. What is the ratio of the Area (% of total land area) in Other small states in 1996 to that in 2002?
Make the answer very short. 1. What is the ratio of the Area (% of total land area) in Indonesia in 1996 to that in 2002?
Your response must be concise. 0.89. What is the ratio of the Area (% of total land area) in New Zealand in 1996 to that in 2002?
Ensure brevity in your answer.  1.23. What is the ratio of the Area (% of total land area) of New Zealand in 1997 to that in 1998?
Your answer should be very brief. 1. What is the ratio of the Area (% of total land area) in Other small states in 1997 to that in 1999?
Make the answer very short. 1. What is the ratio of the Area (% of total land area) of Indonesia in 1997 to that in 1999?
Provide a short and direct response. 0.95. What is the ratio of the Area (% of total land area) of Europe(all income levels) in 1997 to that in 2000?
Your response must be concise. 1. What is the ratio of the Area (% of total land area) of Indonesia in 1997 to that in 2000?
Provide a short and direct response. 0.92. What is the ratio of the Area (% of total land area) in New Zealand in 1997 to that in 2000?
Your answer should be compact. 0.97. What is the ratio of the Area (% of total land area) of Europe(all income levels) in 1997 to that in 2001?
Offer a very short reply. 1.01. What is the ratio of the Area (% of total land area) of Indonesia in 1997 to that in 2001?
Ensure brevity in your answer.  0.91. What is the ratio of the Area (% of total land area) in New Zealand in 1997 to that in 2001?
Keep it short and to the point. 0.97. What is the ratio of the Area (% of total land area) in Europe(all income levels) in 1997 to that in 2002?
Keep it short and to the point. 1.01. What is the ratio of the Area (% of total land area) of Other small states in 1997 to that in 2002?
Give a very brief answer. 1. What is the ratio of the Area (% of total land area) in Indonesia in 1997 to that in 2002?
Offer a terse response. 0.9. What is the ratio of the Area (% of total land area) in New Zealand in 1997 to that in 2002?
Offer a terse response. 1.23. What is the ratio of the Area (% of total land area) in Europe(all income levels) in 1998 to that in 1999?
Your answer should be very brief. 1. What is the ratio of the Area (% of total land area) in Other small states in 1998 to that in 1999?
Your answer should be very brief. 1. What is the ratio of the Area (% of total land area) in Indonesia in 1998 to that in 1999?
Give a very brief answer. 0.96. What is the ratio of the Area (% of total land area) of Other small states in 1998 to that in 2000?
Offer a very short reply. 1. What is the ratio of the Area (% of total land area) of Indonesia in 1998 to that in 2000?
Keep it short and to the point. 0.93. What is the ratio of the Area (% of total land area) in New Zealand in 1998 to that in 2000?
Keep it short and to the point. 0.97. What is the ratio of the Area (% of total land area) of Indonesia in 1998 to that in 2001?
Give a very brief answer. 0.92. What is the ratio of the Area (% of total land area) in New Zealand in 1998 to that in 2001?
Your answer should be very brief. 0.97. What is the ratio of the Area (% of total land area) of Europe(all income levels) in 1998 to that in 2002?
Keep it short and to the point. 1.01. What is the ratio of the Area (% of total land area) of Other small states in 1998 to that in 2002?
Offer a very short reply. 1. What is the ratio of the Area (% of total land area) of Indonesia in 1998 to that in 2002?
Your response must be concise. 0.91. What is the ratio of the Area (% of total land area) of New Zealand in 1998 to that in 2002?
Provide a succinct answer. 1.23. What is the ratio of the Area (% of total land area) of Indonesia in 1999 to that in 2000?
Keep it short and to the point. 0.97. What is the ratio of the Area (% of total land area) in New Zealand in 1999 to that in 2000?
Your answer should be very brief. 0.97. What is the ratio of the Area (% of total land area) in Europe(all income levels) in 1999 to that in 2001?
Make the answer very short. 1. What is the ratio of the Area (% of total land area) in Other small states in 1999 to that in 2001?
Provide a short and direct response. 1. What is the ratio of the Area (% of total land area) of Indonesia in 1999 to that in 2001?
Provide a short and direct response. 0.96. What is the ratio of the Area (% of total land area) in New Zealand in 1999 to that in 2001?
Ensure brevity in your answer.  0.97. What is the ratio of the Area (% of total land area) of Indonesia in 1999 to that in 2002?
Your answer should be very brief. 0.95. What is the ratio of the Area (% of total land area) of New Zealand in 1999 to that in 2002?
Offer a terse response. 1.23. What is the ratio of the Area (% of total land area) in Other small states in 2000 to that in 2001?
Give a very brief answer. 1. What is the ratio of the Area (% of total land area) of Europe(all income levels) in 2000 to that in 2002?
Ensure brevity in your answer.  1.01. What is the ratio of the Area (% of total land area) in Other small states in 2000 to that in 2002?
Give a very brief answer. 1. What is the ratio of the Area (% of total land area) of Indonesia in 2000 to that in 2002?
Ensure brevity in your answer.  0.98. What is the ratio of the Area (% of total land area) in New Zealand in 2000 to that in 2002?
Your answer should be compact. 1.27. What is the ratio of the Area (% of total land area) in Europe(all income levels) in 2001 to that in 2002?
Offer a very short reply. 1. What is the ratio of the Area (% of total land area) in Other small states in 2001 to that in 2002?
Make the answer very short. 1. What is the ratio of the Area (% of total land area) in New Zealand in 2001 to that in 2002?
Your response must be concise. 1.27. What is the difference between the highest and the second highest Area (% of total land area) in Europe(all income levels)?
Give a very brief answer. 0.08. What is the difference between the highest and the second highest Area (% of total land area) of Other small states?
Your answer should be very brief. 0.02. What is the difference between the highest and the second highest Area (% of total land area) of Indonesia?
Ensure brevity in your answer.  0.27. What is the difference between the highest and the second highest Area (% of total land area) in New Zealand?
Offer a terse response. 0.02. What is the difference between the highest and the lowest Area (% of total land area) in Europe(all income levels)?
Provide a succinct answer. 0.45. What is the difference between the highest and the lowest Area (% of total land area) in Other small states?
Make the answer very short. 0.15. What is the difference between the highest and the lowest Area (% of total land area) of Indonesia?
Give a very brief answer. 2.88. What is the difference between the highest and the lowest Area (% of total land area) of New Zealand?
Your answer should be very brief. 12.6. 